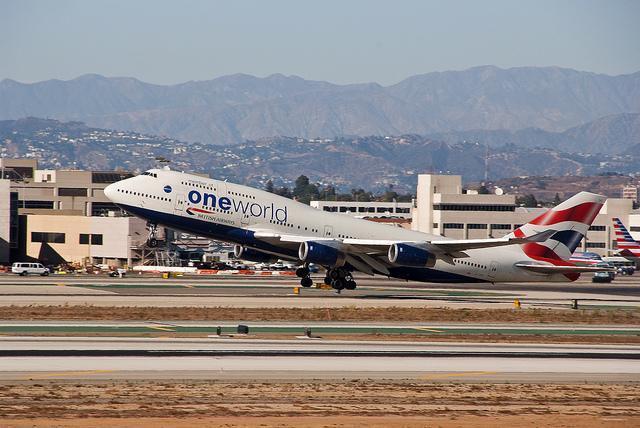How many people are on the train platform?
Give a very brief answer. 0. 